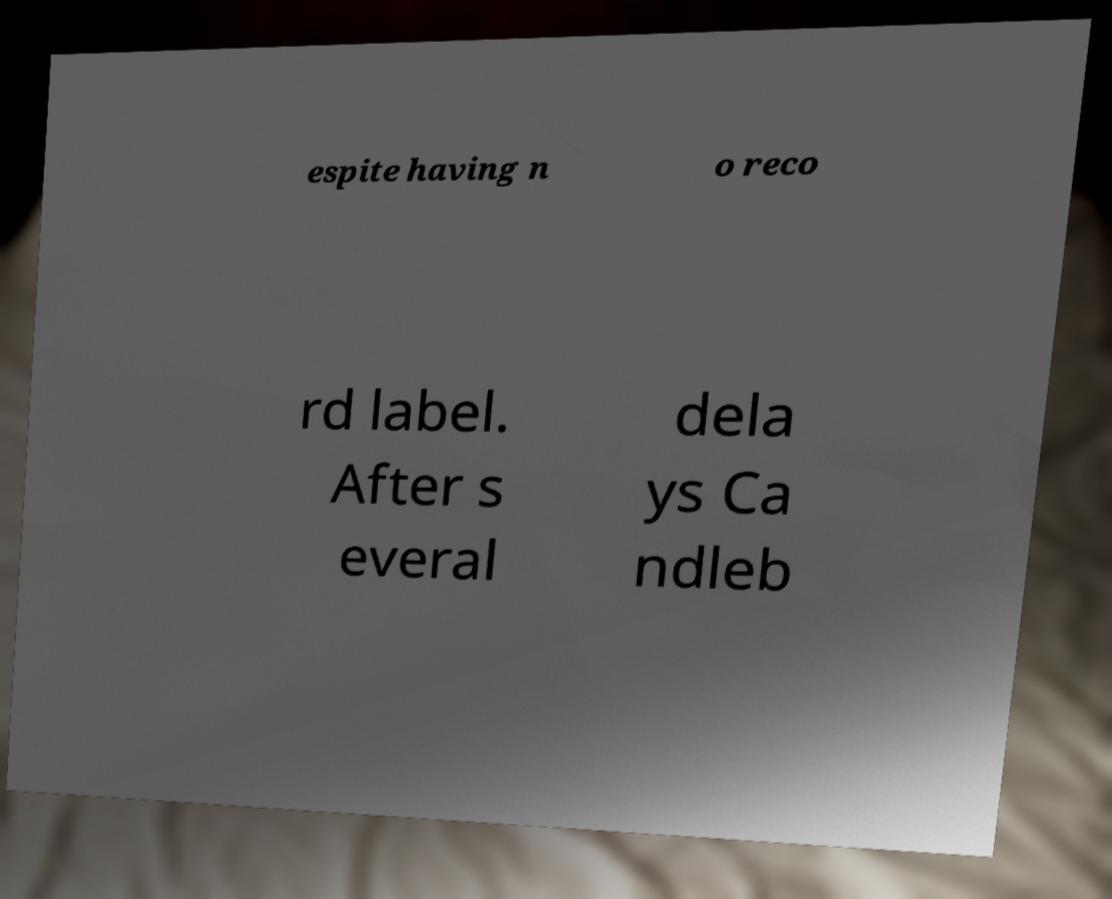There's text embedded in this image that I need extracted. Can you transcribe it verbatim? espite having n o reco rd label. After s everal dela ys Ca ndleb 